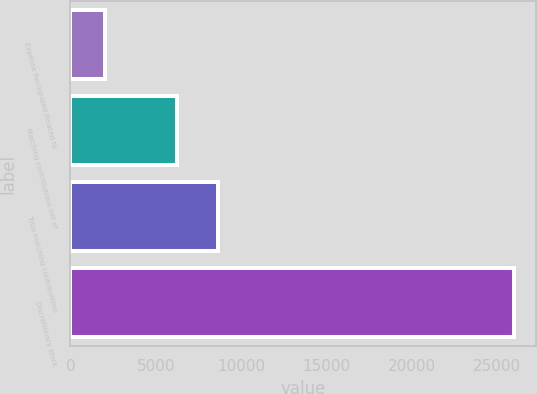<chart> <loc_0><loc_0><loc_500><loc_500><bar_chart><fcel>Expense Recognized Related to<fcel>Matching contributions net of<fcel>Total matching contributions<fcel>Discretionary stock<nl><fcel>2014<fcel>6222<fcel>8617.8<fcel>25972<nl></chart> 